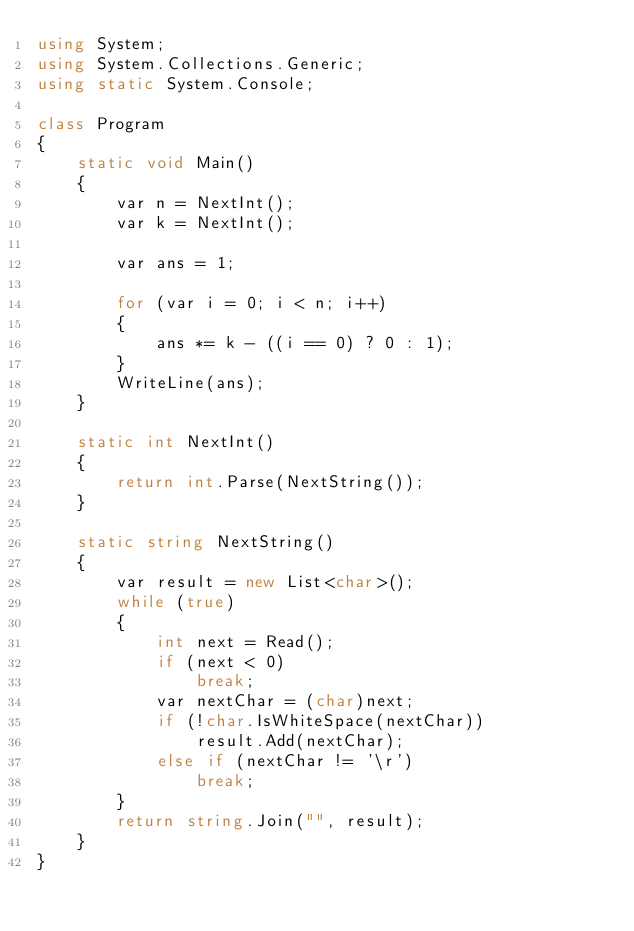<code> <loc_0><loc_0><loc_500><loc_500><_C#_>using System;
using System.Collections.Generic;
using static System.Console;

class Program
{
    static void Main()
    {
        var n = NextInt();
        var k = NextInt();

        var ans = 1;

        for (var i = 0; i < n; i++)
        {
            ans *= k - ((i == 0) ? 0 : 1);
        }
        WriteLine(ans);
    }

    static int NextInt()
    {
        return int.Parse(NextString());
    }

    static string NextString()
    {
        var result = new List<char>();
        while (true)
        {
            int next = Read();
            if (next < 0)
                break;
            var nextChar = (char)next;
            if (!char.IsWhiteSpace(nextChar))
                result.Add(nextChar);
            else if (nextChar != '\r')
                break;
        }
        return string.Join("", result);
    }
}
</code> 